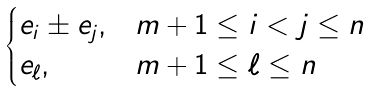<formula> <loc_0><loc_0><loc_500><loc_500>\begin{cases} e _ { i } \pm e _ { j } , & m + 1 \leq i < j \leq n \\ e _ { \ell } , & m + 1 \leq \ell \leq n \end{cases}</formula> 